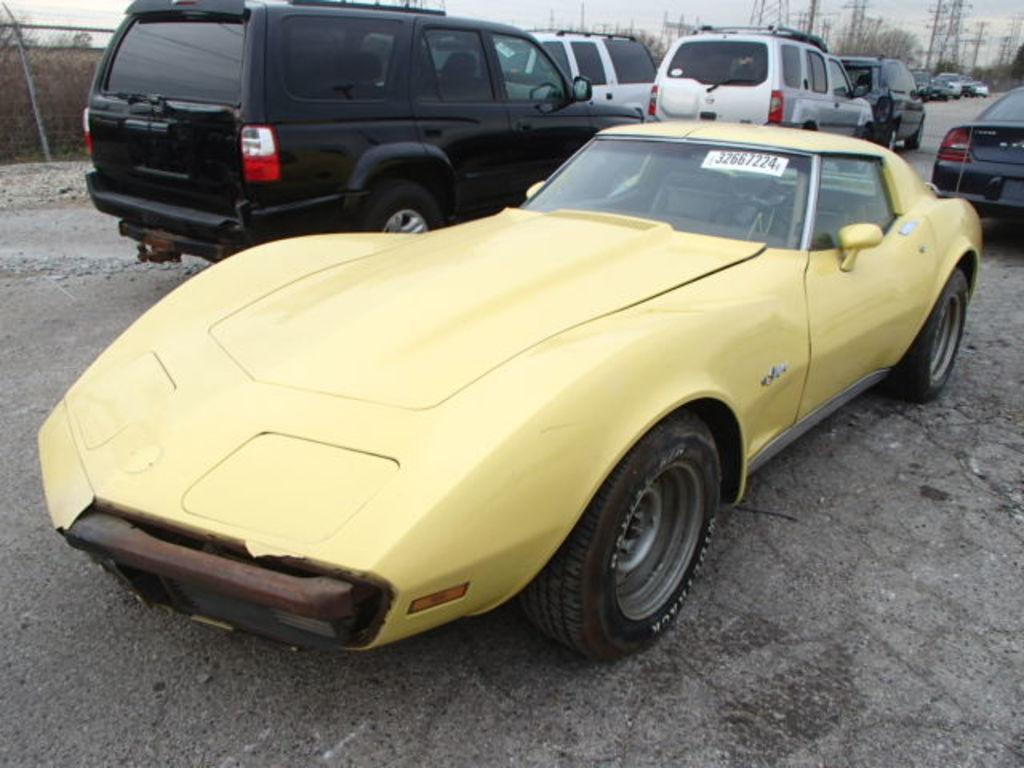What types of objects can be seen in the image? There are vehicles in the image. Are there any specific markings or details on the vehicles? Yes, there are numbers written in the image. What can be seen in the background of the image? The sky and electric towers are visible in the background of the image. What type of sticks can be seen holding up the note in the image? There is no note or sticks present in the image. What riddle is written on the electric towers in the image? There is no riddle written on the electric towers in the image; they are simply depicted as part of the background. 